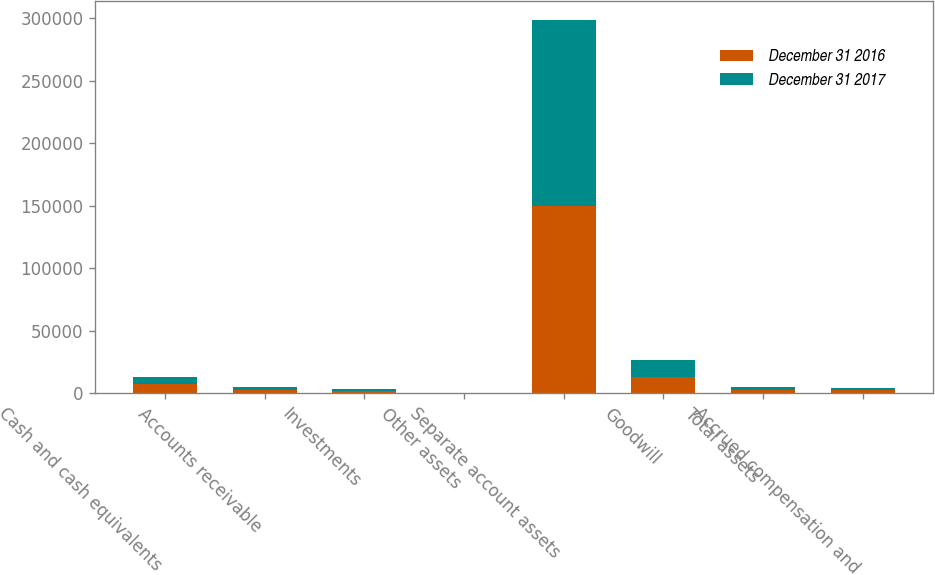<chart> <loc_0><loc_0><loc_500><loc_500><stacked_bar_chart><ecel><fcel>Cash and cash equivalents<fcel>Accounts receivable<fcel>Investments<fcel>Other assets<fcel>Separate account assets<fcel>Goodwill<fcel>Total assets<fcel>Accrued compensation and<nl><fcel>December 31 2016<fcel>6894<fcel>2699<fcel>1981<fcel>66<fcel>149937<fcel>13220<fcel>2426<fcel>2153<nl><fcel>December 31 2017<fcel>6091<fcel>2115<fcel>1595<fcel>63<fcel>149089<fcel>13118<fcel>2426<fcel>1880<nl></chart> 